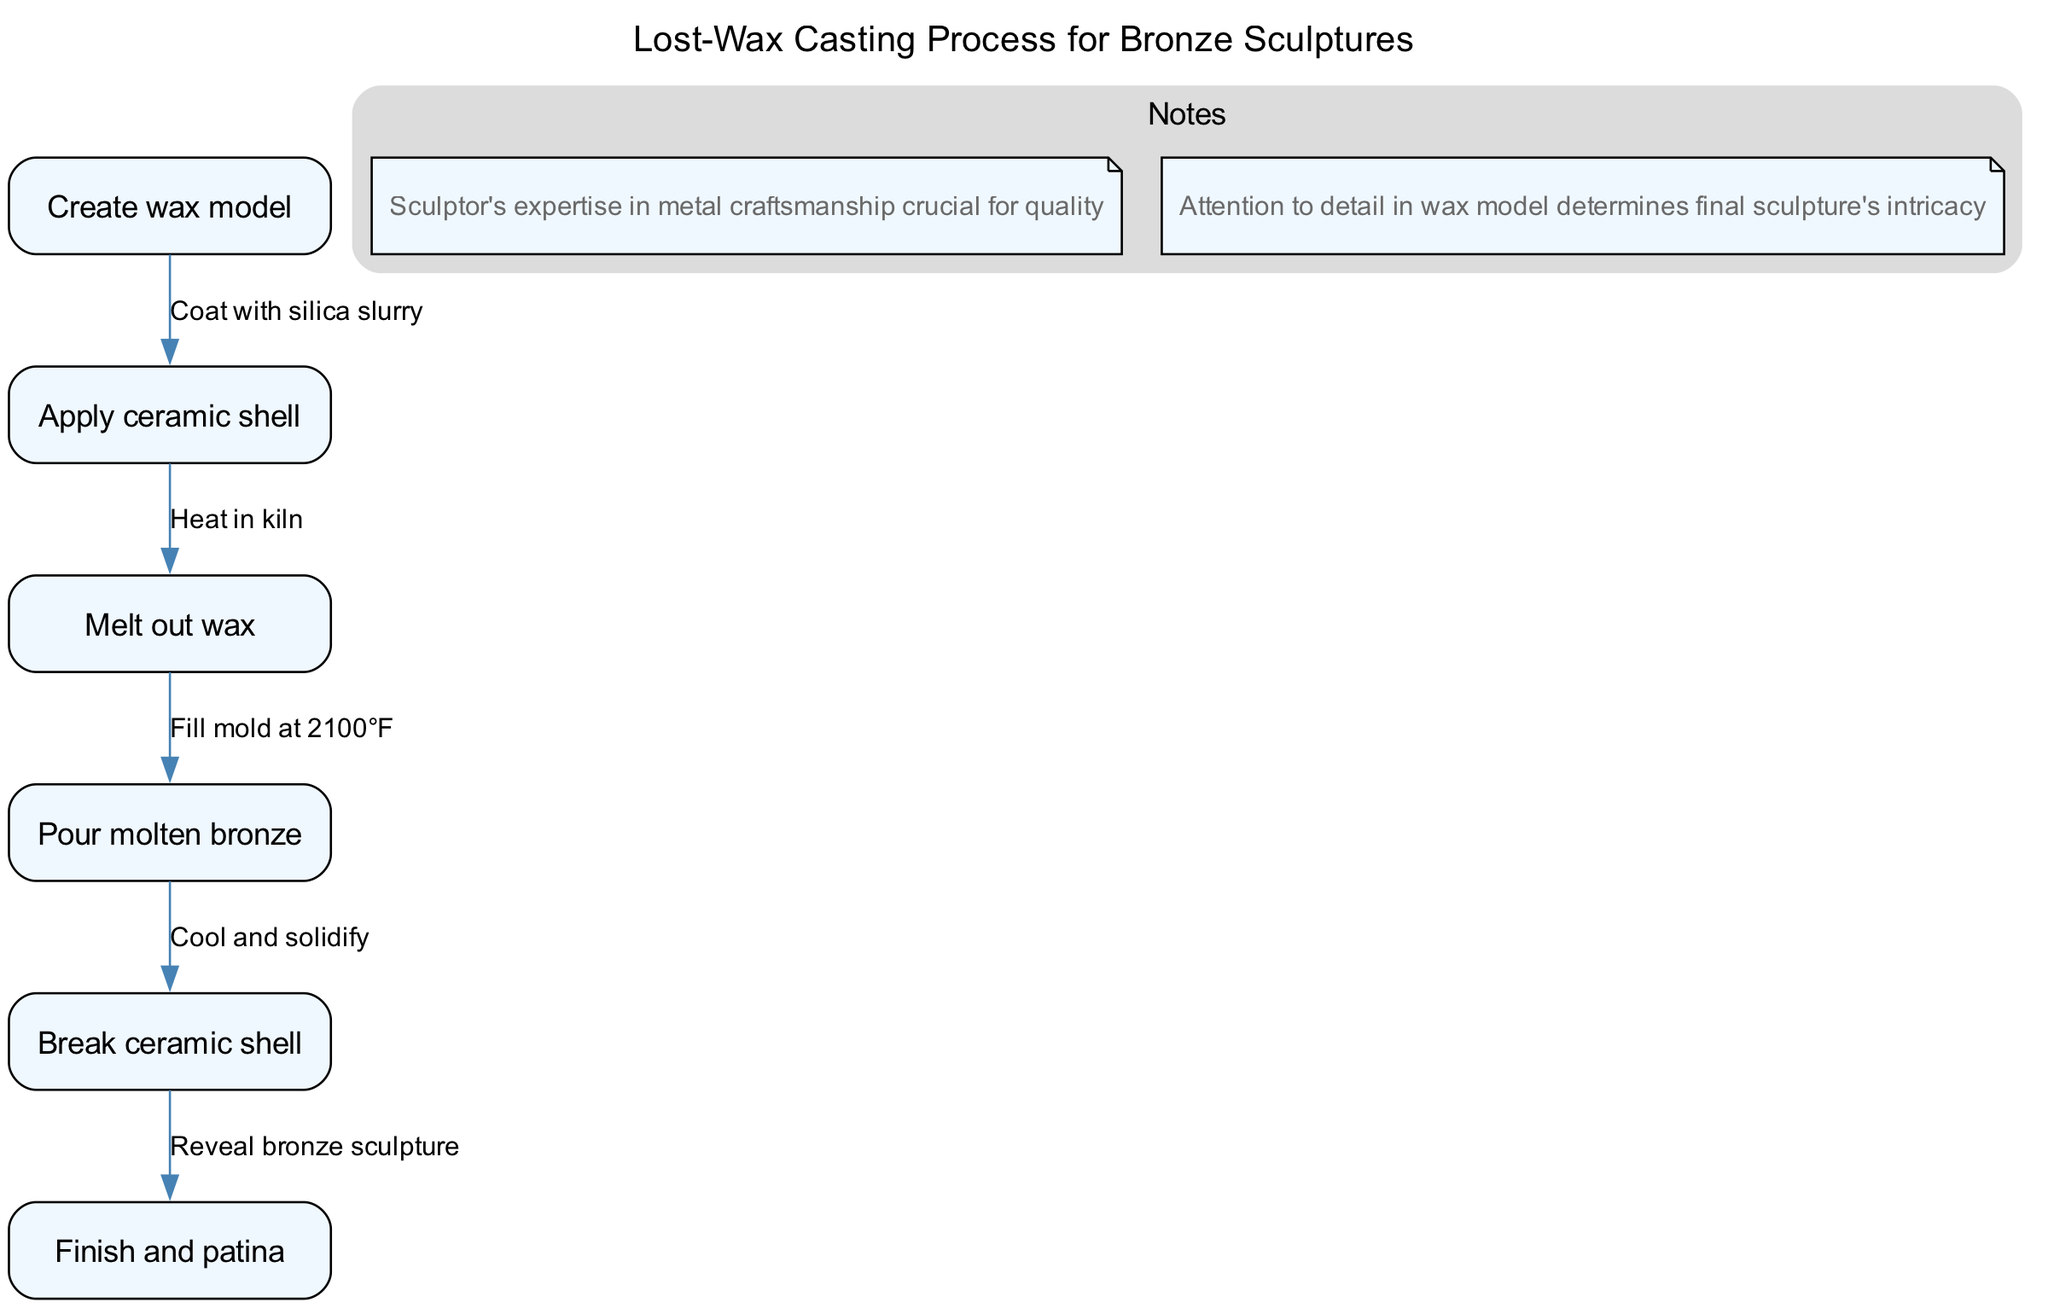What is the first step in the lost-wax casting process? The diagram indicates that the first step is labeled "Create wax model". Therefore, looking at the nodes, the first one (ID 1) corresponds to creating the wax model.
Answer: Create wax model How many nodes are in the diagram? By counting the nodes listed in the data, there are a total of six distinct nodes representing steps in the process.
Answer: 6 What is the label of the last process step? The last node in the diagram is labeled "Finish and patina". This is found by examining the last node listed (ID 6).
Answer: Finish and patina Which step follows 'Melt out wax'? According to the edges in the diagram, the step that directly follows "Melt out wax" (ID 3) is "Pour molten bronze" (ID 4), as indicated by the directed edge from node 3 to node 4.
Answer: Pour molten bronze What action occurs after pouring the molten bronze? Following the step "Pour molten bronze" (ID 4), the next action is "Cool and solidify" (ID 5), as this is the next step in the flow outlined by the edges.
Answer: Cool and solidify What is the relationship between 'Apply ceramic shell' and 'Melt out wax'? The diagram shows a directed edge from "Apply ceramic shell" (ID 2) to "Melt out wax" (ID 3) labeled "Heat in kiln". This indicates that heating in the kiln is the action that facilitates the next step.
Answer: Heat in kiln Which step is directly connected to 'Break ceramic shell'? According to the diagram, "Break ceramic shell" (ID 5) is directly followed by "Finish and patina" (ID 6), as seen through the edge leading into node 6.
Answer: Finish and patina How many edges are present in the diagram? Counting the edges listed in the data, there are a total of five edges that define the relationships between the steps in the process.
Answer: 5 